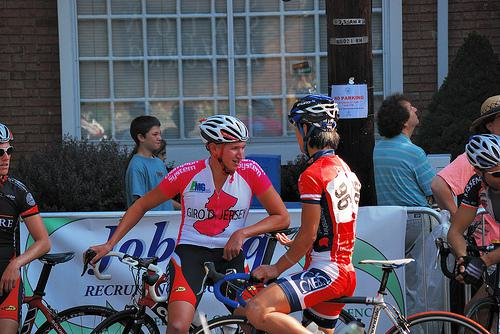How many unicorns are there in the image? 0 